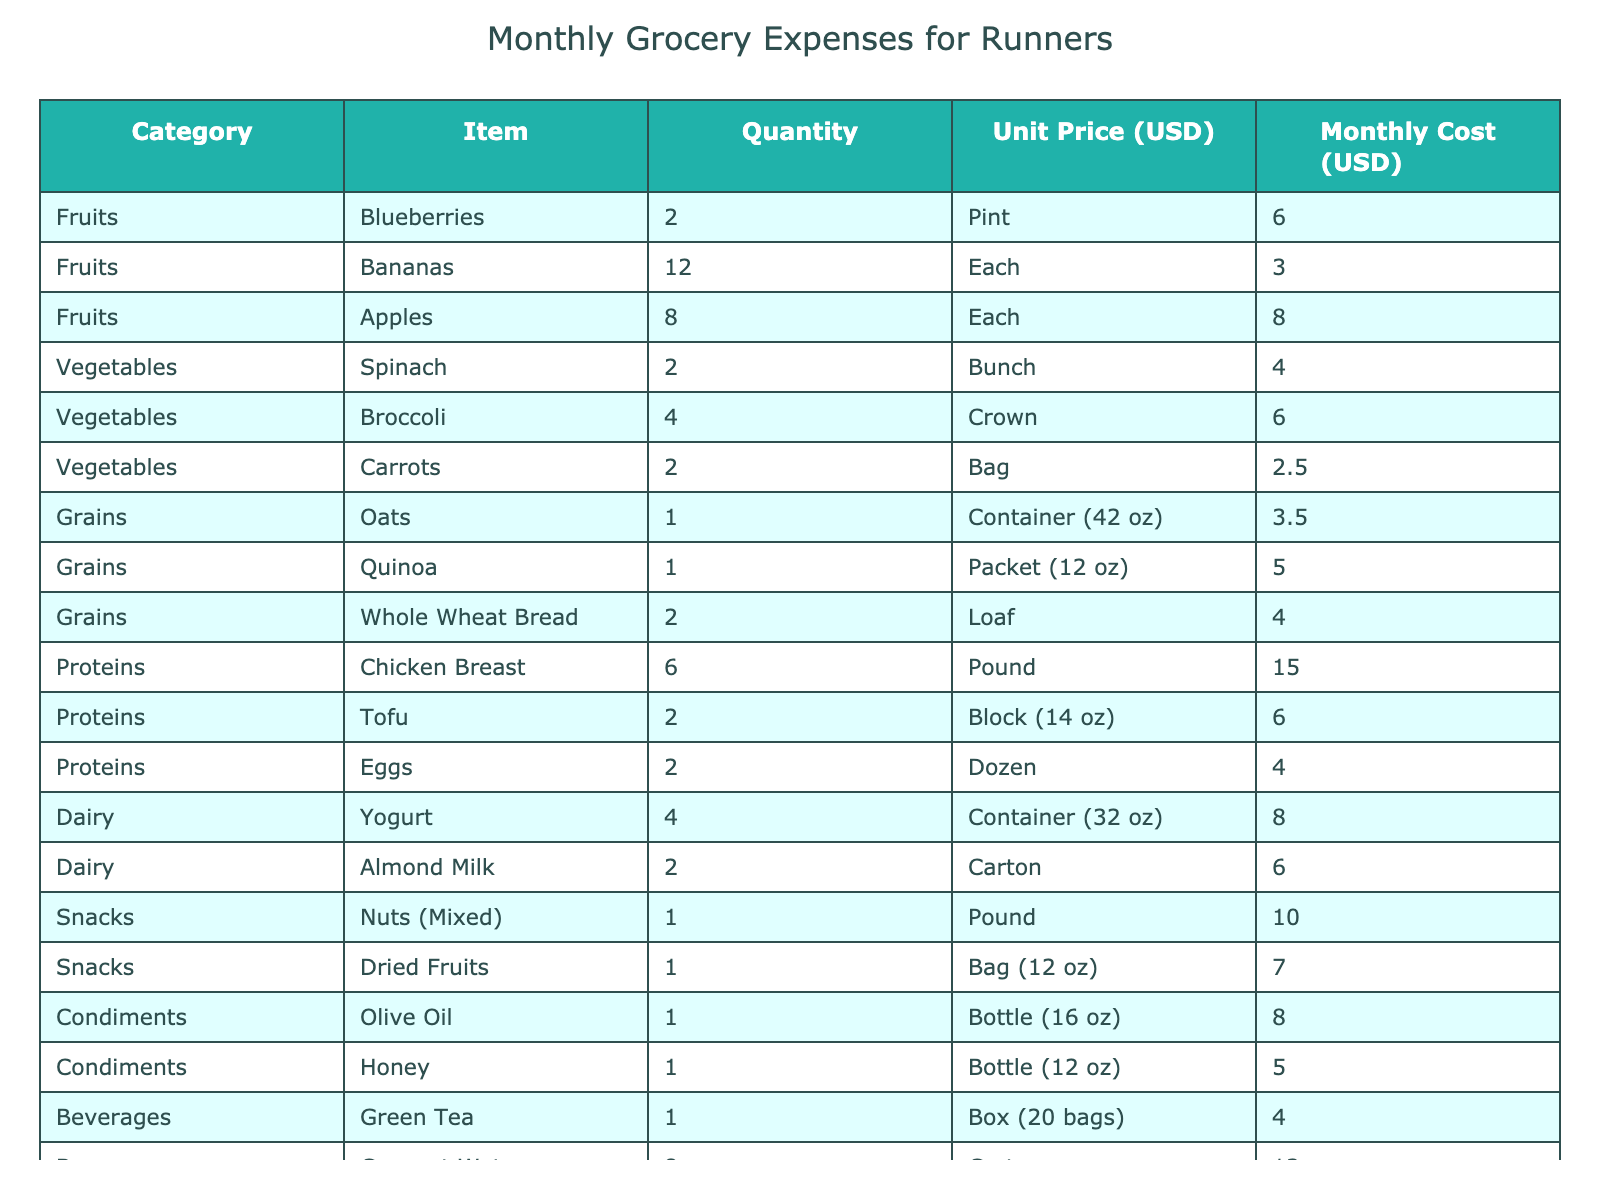What's the total monthly cost for fruits? To find the total cost for fruits, add the monthly costs of Blueberries ($6.00), Bananas ($3.00), and Apples ($8.00), which sums up to $6.00 + $3.00 + $8.00 = $17.00.
Answer: $17.00 How much do vegetables cost in total? The monthly costs for Spinach ($4.00), Broccoli ($6.00), and Carrots ($2.50) need to be added together. So, $4.00 + $6.00 + $2.50 = $12.50.
Answer: $12.50 What is the cheapest protein source? By examining the monthly costs for proteins, Chicken Breast is $15.00, Tofu is $6.00, and Eggs are $4.00. The cheapest is Eggs at $4.00.
Answer: Eggs Are the costs of nuts and dried fruits more than the monthly cost of chicken breast? The cost for nuts is $10.00 and for dried fruits is $7.00, totaling $10.00 + $7.00 = $17.00. Since $17.00 is greater than the cost of chicken breast ($15.00), the statement is true.
Answer: Yes What is the average cost per item in the dairy category? The monthly costs for yogurt ($8.00) and almond milk ($6.00) add up to $14.00. There are 2 items, so the average cost is $14.00 / 2 = $7.00.
Answer: $7.00 How much more do snacks cost compared to dairy? The total cost for snacks is $10.00 (nuts) + $7.00 (dried fruits) = $17.00. The total cost for dairy is $14.00 (yogurt + almond milk). Thus, $17.00 - $14.00 = $3.00 more.
Answer: $3.00 What is the cost difference between the most and least expensive item in grains? The cost of oats is $3.50, while quinoa is $5.00. The difference is $5.00 - $3.50 = $1.50.
Answer: $1.50 Which category has the highest total monthly cost? Calculating each category's total cost: Fruits ($17.00), Vegetables ($12.50), Grains ($12.50), Proteins ($25.00), Dairy ($14.00), Snacks ($17.00), Condiments ($13.00), Beverages ($16.00). The highest is Proteins at $25.00.
Answer: Proteins How much do beverages cost in total compared to grains? Beverages total $4.00 (green tea) + $12.00 (coconut water) = $16.00. Grains total $3.50 (oats) + $5.00 (quinoa) + $4.00 (whole wheat bread) = $12.50. The difference is $16.00 - $12.50 = $3.50 more for beverages.
Answer: $3.50 Is the monthly cost for condiments greater than that for grains? Condiments total $8.00 (olive oil) + $5.00 (honey) = $13.00. Grains total $12.50, so $13.00 is greater than $12.50. Therefore, the statement is true.
Answer: Yes 